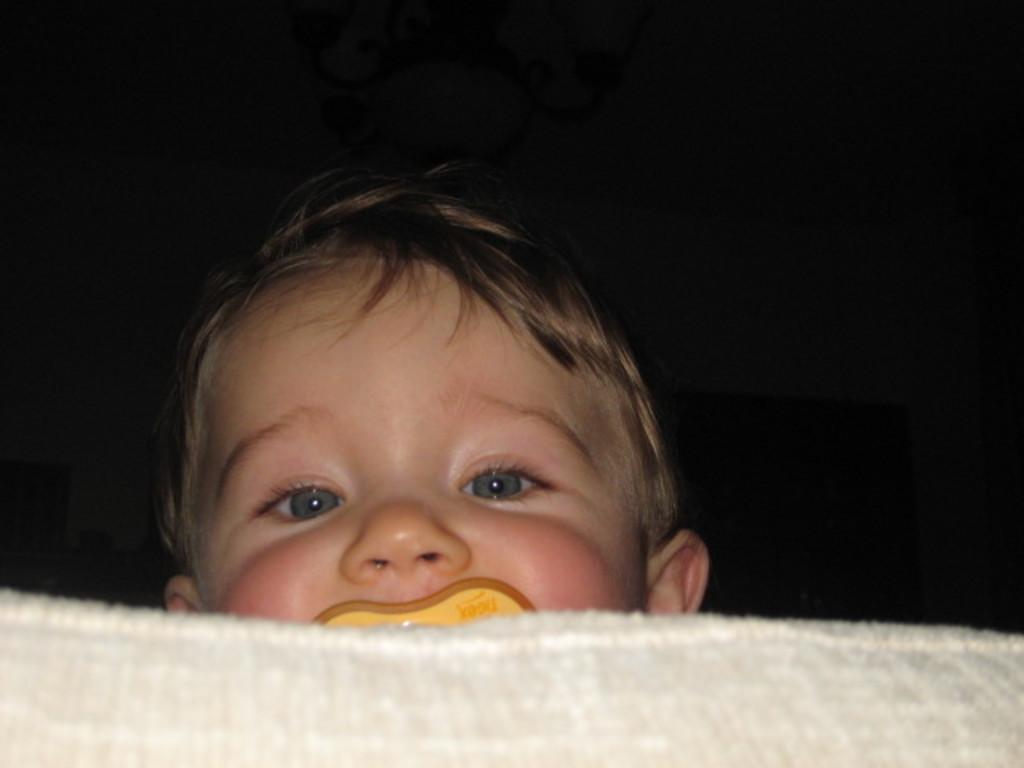How would you summarize this image in a sentence or two? At the bottom of this image there is a white color cloth. It seems to be a bed. Behind there is a baby. The background is in black color. 